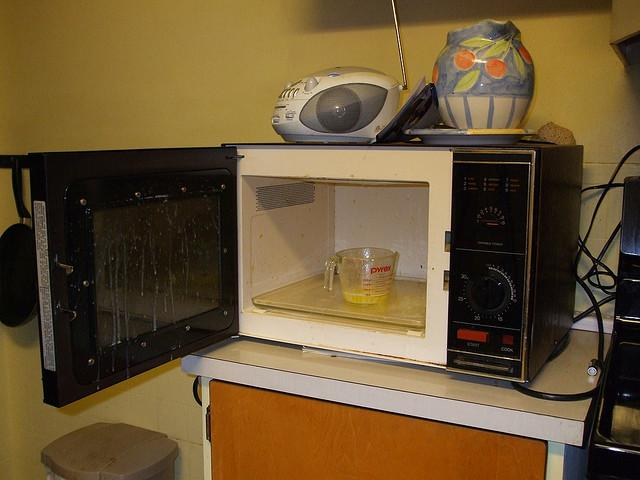How is the measuring cup being heated? Please explain your reasoning. microwave. The measuring cup is in an oven. it does not have heating elements, so it is not a convection oven. 